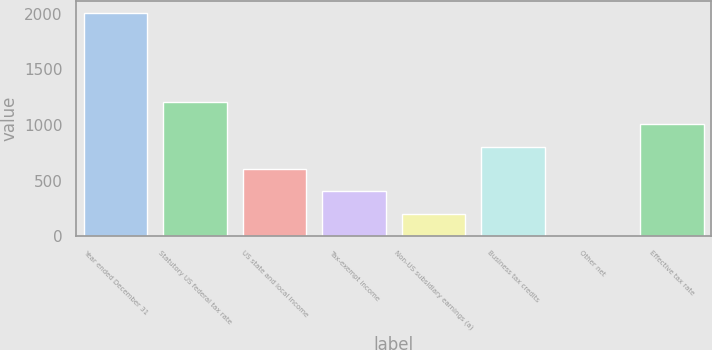Convert chart. <chart><loc_0><loc_0><loc_500><loc_500><bar_chart><fcel>Year ended December 31<fcel>Statutory US federal tax rate<fcel>US state and local income<fcel>Tax-exempt income<fcel>Non-US subsidiary earnings (a)<fcel>Business tax credits<fcel>Other net<fcel>Effective tax rate<nl><fcel>2010<fcel>1206.08<fcel>603.14<fcel>402.16<fcel>201.18<fcel>804.12<fcel>0.2<fcel>1005.1<nl></chart> 